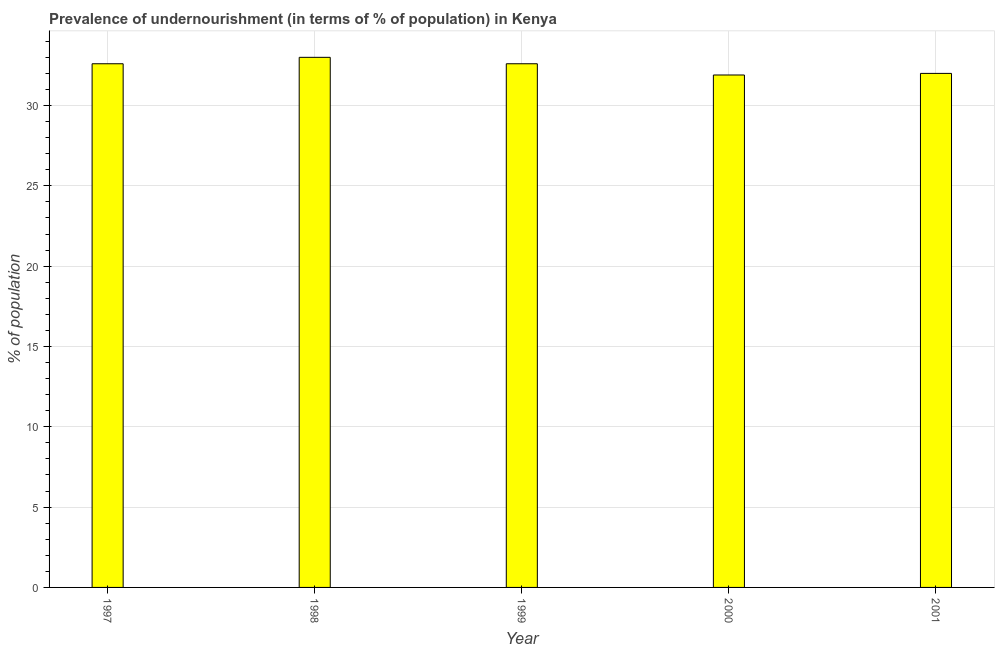Does the graph contain any zero values?
Your answer should be compact. No. Does the graph contain grids?
Your answer should be compact. Yes. What is the title of the graph?
Offer a very short reply. Prevalence of undernourishment (in terms of % of population) in Kenya. What is the label or title of the Y-axis?
Keep it short and to the point. % of population. What is the percentage of undernourished population in 1999?
Ensure brevity in your answer.  32.6. Across all years, what is the minimum percentage of undernourished population?
Provide a short and direct response. 31.9. In which year was the percentage of undernourished population maximum?
Offer a terse response. 1998. What is the sum of the percentage of undernourished population?
Provide a short and direct response. 162.1. What is the average percentage of undernourished population per year?
Ensure brevity in your answer.  32.42. What is the median percentage of undernourished population?
Give a very brief answer. 32.6. In how many years, is the percentage of undernourished population greater than 31 %?
Your answer should be very brief. 5. Do a majority of the years between 1999 and 1998 (inclusive) have percentage of undernourished population greater than 15 %?
Provide a short and direct response. No. What is the ratio of the percentage of undernourished population in 1999 to that in 2000?
Ensure brevity in your answer.  1.02. Is the difference between the percentage of undernourished population in 1999 and 2000 greater than the difference between any two years?
Provide a succinct answer. No. What is the difference between the highest and the second highest percentage of undernourished population?
Offer a terse response. 0.4. Is the sum of the percentage of undernourished population in 1997 and 2000 greater than the maximum percentage of undernourished population across all years?
Ensure brevity in your answer.  Yes. In how many years, is the percentage of undernourished population greater than the average percentage of undernourished population taken over all years?
Ensure brevity in your answer.  3. How many bars are there?
Provide a short and direct response. 5. How many years are there in the graph?
Give a very brief answer. 5. What is the % of population of 1997?
Keep it short and to the point. 32.6. What is the % of population in 1999?
Offer a terse response. 32.6. What is the % of population of 2000?
Your answer should be very brief. 31.9. What is the difference between the % of population in 1997 and 1999?
Offer a very short reply. 0. What is the difference between the % of population in 1997 and 2000?
Make the answer very short. 0.7. What is the difference between the % of population in 1997 and 2001?
Your answer should be compact. 0.6. What is the difference between the % of population in 1998 and 2001?
Offer a terse response. 1. What is the difference between the % of population in 1999 and 2000?
Keep it short and to the point. 0.7. What is the ratio of the % of population in 1997 to that in 1998?
Your response must be concise. 0.99. What is the ratio of the % of population in 1997 to that in 1999?
Provide a succinct answer. 1. What is the ratio of the % of population in 1997 to that in 2000?
Your answer should be very brief. 1.02. What is the ratio of the % of population in 1998 to that in 2000?
Your answer should be compact. 1.03. What is the ratio of the % of population in 1998 to that in 2001?
Give a very brief answer. 1.03. What is the ratio of the % of population in 1999 to that in 2000?
Make the answer very short. 1.02. What is the ratio of the % of population in 1999 to that in 2001?
Your answer should be compact. 1.02. What is the ratio of the % of population in 2000 to that in 2001?
Offer a terse response. 1. 